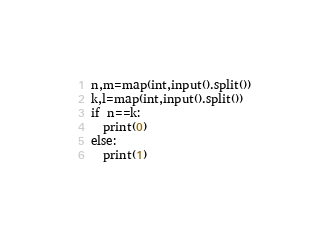Convert code to text. <code><loc_0><loc_0><loc_500><loc_500><_Python_>n,m=map(int,input().split())
k,l=map(int,input().split())
if n==k:
  print(0)
else:
  print(1)</code> 